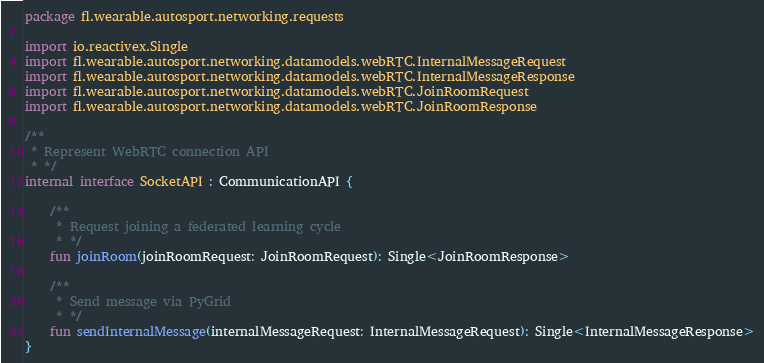<code> <loc_0><loc_0><loc_500><loc_500><_Kotlin_>package fl.wearable.autosport.networking.requests

import io.reactivex.Single
import fl.wearable.autosport.networking.datamodels.webRTC.InternalMessageRequest
import fl.wearable.autosport.networking.datamodels.webRTC.InternalMessageResponse
import fl.wearable.autosport.networking.datamodels.webRTC.JoinRoomRequest
import fl.wearable.autosport.networking.datamodels.webRTC.JoinRoomResponse

/**
 * Represent WebRTC connection API
 * */
internal interface SocketAPI : CommunicationAPI {

    /**
     * Request joining a federated learning cycle
     * */
    fun joinRoom(joinRoomRequest: JoinRoomRequest): Single<JoinRoomResponse>

    /**
     * Send message via PyGrid
     * */
    fun sendInternalMessage(internalMessageRequest: InternalMessageRequest): Single<InternalMessageResponse>
}</code> 